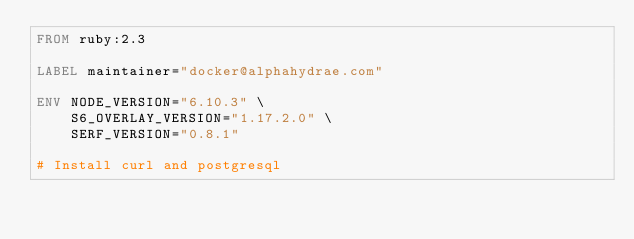<code> <loc_0><loc_0><loc_500><loc_500><_Dockerfile_>FROM ruby:2.3

LABEL maintainer="docker@alphahydrae.com"

ENV NODE_VERSION="6.10.3" \
    S6_OVERLAY_VERSION="1.17.2.0" \
    SERF_VERSION="0.8.1"

# Install curl and postgresql</code> 